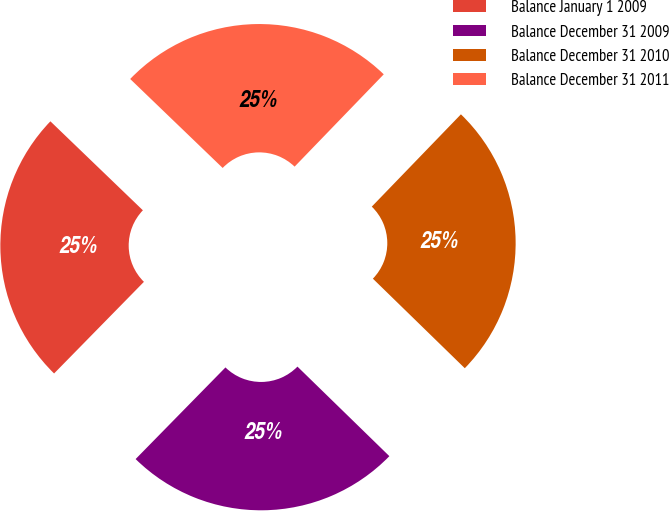Convert chart. <chart><loc_0><loc_0><loc_500><loc_500><pie_chart><fcel>Balance January 1 2009<fcel>Balance December 31 2009<fcel>Balance December 31 2010<fcel>Balance December 31 2011<nl><fcel>24.85%<fcel>25.05%<fcel>25.07%<fcel>25.03%<nl></chart> 